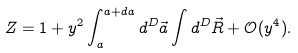Convert formula to latex. <formula><loc_0><loc_0><loc_500><loc_500>Z = 1 + y ^ { 2 } \int _ { a } ^ { a + d a } d ^ { D } \vec { a } \int d ^ { D } \vec { R } + \mathcal { O } ( y ^ { 4 } ) .</formula> 